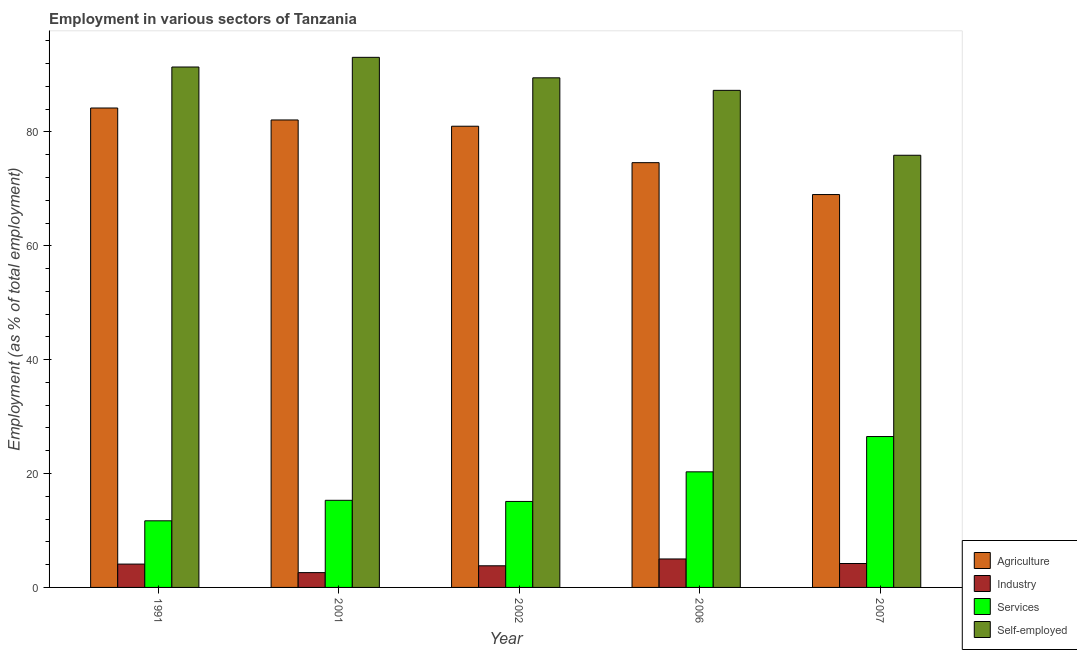Are the number of bars per tick equal to the number of legend labels?
Make the answer very short. Yes. How many bars are there on the 3rd tick from the left?
Your answer should be very brief. 4. What is the percentage of self employed workers in 2007?
Offer a terse response. 75.9. Across all years, what is the maximum percentage of self employed workers?
Your response must be concise. 93.1. Across all years, what is the minimum percentage of workers in agriculture?
Your answer should be compact. 69. In which year was the percentage of self employed workers minimum?
Your answer should be compact. 2007. What is the total percentage of workers in agriculture in the graph?
Make the answer very short. 390.9. What is the difference between the percentage of workers in agriculture in 1991 and that in 2002?
Make the answer very short. 3.2. What is the difference between the percentage of workers in agriculture in 2001 and the percentage of workers in services in 2006?
Your answer should be very brief. 7.5. What is the average percentage of self employed workers per year?
Provide a short and direct response. 87.44. What is the ratio of the percentage of workers in industry in 2002 to that in 2006?
Your response must be concise. 0.76. Is the percentage of self employed workers in 1991 less than that in 2002?
Give a very brief answer. No. What is the difference between the highest and the second highest percentage of workers in services?
Your answer should be very brief. 6.2. What is the difference between the highest and the lowest percentage of workers in services?
Ensure brevity in your answer.  14.8. Is it the case that in every year, the sum of the percentage of self employed workers and percentage of workers in services is greater than the sum of percentage of workers in agriculture and percentage of workers in industry?
Ensure brevity in your answer.  Yes. What does the 1st bar from the left in 2001 represents?
Your answer should be very brief. Agriculture. What does the 4th bar from the right in 2006 represents?
Your answer should be very brief. Agriculture. Is it the case that in every year, the sum of the percentage of workers in agriculture and percentage of workers in industry is greater than the percentage of workers in services?
Your answer should be compact. Yes. How many bars are there?
Give a very brief answer. 20. Are all the bars in the graph horizontal?
Your answer should be very brief. No. Does the graph contain any zero values?
Your answer should be very brief. No. Where does the legend appear in the graph?
Offer a terse response. Bottom right. How many legend labels are there?
Your response must be concise. 4. What is the title of the graph?
Provide a short and direct response. Employment in various sectors of Tanzania. Does "Management rating" appear as one of the legend labels in the graph?
Offer a very short reply. No. What is the label or title of the Y-axis?
Provide a short and direct response. Employment (as % of total employment). What is the Employment (as % of total employment) in Agriculture in 1991?
Offer a terse response. 84.2. What is the Employment (as % of total employment) of Industry in 1991?
Your answer should be very brief. 4.1. What is the Employment (as % of total employment) in Services in 1991?
Make the answer very short. 11.7. What is the Employment (as % of total employment) of Self-employed in 1991?
Your answer should be very brief. 91.4. What is the Employment (as % of total employment) of Agriculture in 2001?
Your answer should be compact. 82.1. What is the Employment (as % of total employment) of Industry in 2001?
Your answer should be very brief. 2.6. What is the Employment (as % of total employment) in Services in 2001?
Your answer should be compact. 15.3. What is the Employment (as % of total employment) of Self-employed in 2001?
Your response must be concise. 93.1. What is the Employment (as % of total employment) of Agriculture in 2002?
Your answer should be compact. 81. What is the Employment (as % of total employment) in Industry in 2002?
Offer a very short reply. 3.8. What is the Employment (as % of total employment) of Services in 2002?
Your answer should be compact. 15.1. What is the Employment (as % of total employment) in Self-employed in 2002?
Your response must be concise. 89.5. What is the Employment (as % of total employment) in Agriculture in 2006?
Provide a succinct answer. 74.6. What is the Employment (as % of total employment) in Industry in 2006?
Make the answer very short. 5. What is the Employment (as % of total employment) in Services in 2006?
Your answer should be compact. 20.3. What is the Employment (as % of total employment) of Self-employed in 2006?
Provide a succinct answer. 87.3. What is the Employment (as % of total employment) in Agriculture in 2007?
Ensure brevity in your answer.  69. What is the Employment (as % of total employment) in Industry in 2007?
Provide a succinct answer. 4.2. What is the Employment (as % of total employment) of Self-employed in 2007?
Your answer should be very brief. 75.9. Across all years, what is the maximum Employment (as % of total employment) in Agriculture?
Provide a succinct answer. 84.2. Across all years, what is the maximum Employment (as % of total employment) of Industry?
Make the answer very short. 5. Across all years, what is the maximum Employment (as % of total employment) in Services?
Your response must be concise. 26.5. Across all years, what is the maximum Employment (as % of total employment) of Self-employed?
Give a very brief answer. 93.1. Across all years, what is the minimum Employment (as % of total employment) in Agriculture?
Provide a succinct answer. 69. Across all years, what is the minimum Employment (as % of total employment) of Industry?
Offer a very short reply. 2.6. Across all years, what is the minimum Employment (as % of total employment) of Services?
Provide a short and direct response. 11.7. Across all years, what is the minimum Employment (as % of total employment) in Self-employed?
Make the answer very short. 75.9. What is the total Employment (as % of total employment) in Agriculture in the graph?
Your answer should be compact. 390.9. What is the total Employment (as % of total employment) in Industry in the graph?
Keep it short and to the point. 19.7. What is the total Employment (as % of total employment) in Services in the graph?
Your response must be concise. 88.9. What is the total Employment (as % of total employment) of Self-employed in the graph?
Your answer should be very brief. 437.2. What is the difference between the Employment (as % of total employment) in Agriculture in 1991 and that in 2001?
Offer a terse response. 2.1. What is the difference between the Employment (as % of total employment) of Self-employed in 1991 and that in 2001?
Your answer should be very brief. -1.7. What is the difference between the Employment (as % of total employment) in Industry in 1991 and that in 2002?
Make the answer very short. 0.3. What is the difference between the Employment (as % of total employment) in Services in 1991 and that in 2002?
Provide a succinct answer. -3.4. What is the difference between the Employment (as % of total employment) of Self-employed in 1991 and that in 2002?
Your response must be concise. 1.9. What is the difference between the Employment (as % of total employment) of Agriculture in 1991 and that in 2006?
Offer a terse response. 9.6. What is the difference between the Employment (as % of total employment) of Industry in 1991 and that in 2006?
Offer a terse response. -0.9. What is the difference between the Employment (as % of total employment) in Services in 1991 and that in 2007?
Ensure brevity in your answer.  -14.8. What is the difference between the Employment (as % of total employment) in Self-employed in 1991 and that in 2007?
Your answer should be compact. 15.5. What is the difference between the Employment (as % of total employment) in Agriculture in 2001 and that in 2002?
Your answer should be very brief. 1.1. What is the difference between the Employment (as % of total employment) of Self-employed in 2001 and that in 2002?
Give a very brief answer. 3.6. What is the difference between the Employment (as % of total employment) of Agriculture in 2001 and that in 2006?
Your answer should be compact. 7.5. What is the difference between the Employment (as % of total employment) in Industry in 2001 and that in 2006?
Offer a terse response. -2.4. What is the difference between the Employment (as % of total employment) in Services in 2001 and that in 2006?
Ensure brevity in your answer.  -5. What is the difference between the Employment (as % of total employment) of Self-employed in 2001 and that in 2006?
Give a very brief answer. 5.8. What is the difference between the Employment (as % of total employment) of Industry in 2001 and that in 2007?
Provide a succinct answer. -1.6. What is the difference between the Employment (as % of total employment) in Services in 2001 and that in 2007?
Give a very brief answer. -11.2. What is the difference between the Employment (as % of total employment) of Self-employed in 2001 and that in 2007?
Keep it short and to the point. 17.2. What is the difference between the Employment (as % of total employment) of Services in 2002 and that in 2006?
Your answer should be very brief. -5.2. What is the difference between the Employment (as % of total employment) of Agriculture in 2002 and that in 2007?
Ensure brevity in your answer.  12. What is the difference between the Employment (as % of total employment) in Industry in 2006 and that in 2007?
Your answer should be very brief. 0.8. What is the difference between the Employment (as % of total employment) in Services in 2006 and that in 2007?
Offer a very short reply. -6.2. What is the difference between the Employment (as % of total employment) of Self-employed in 2006 and that in 2007?
Make the answer very short. 11.4. What is the difference between the Employment (as % of total employment) of Agriculture in 1991 and the Employment (as % of total employment) of Industry in 2001?
Ensure brevity in your answer.  81.6. What is the difference between the Employment (as % of total employment) of Agriculture in 1991 and the Employment (as % of total employment) of Services in 2001?
Give a very brief answer. 68.9. What is the difference between the Employment (as % of total employment) of Agriculture in 1991 and the Employment (as % of total employment) of Self-employed in 2001?
Offer a terse response. -8.9. What is the difference between the Employment (as % of total employment) of Industry in 1991 and the Employment (as % of total employment) of Services in 2001?
Provide a short and direct response. -11.2. What is the difference between the Employment (as % of total employment) of Industry in 1991 and the Employment (as % of total employment) of Self-employed in 2001?
Ensure brevity in your answer.  -89. What is the difference between the Employment (as % of total employment) of Services in 1991 and the Employment (as % of total employment) of Self-employed in 2001?
Offer a terse response. -81.4. What is the difference between the Employment (as % of total employment) of Agriculture in 1991 and the Employment (as % of total employment) of Industry in 2002?
Your answer should be very brief. 80.4. What is the difference between the Employment (as % of total employment) in Agriculture in 1991 and the Employment (as % of total employment) in Services in 2002?
Your answer should be very brief. 69.1. What is the difference between the Employment (as % of total employment) in Agriculture in 1991 and the Employment (as % of total employment) in Self-employed in 2002?
Offer a terse response. -5.3. What is the difference between the Employment (as % of total employment) of Industry in 1991 and the Employment (as % of total employment) of Self-employed in 2002?
Your response must be concise. -85.4. What is the difference between the Employment (as % of total employment) of Services in 1991 and the Employment (as % of total employment) of Self-employed in 2002?
Provide a succinct answer. -77.8. What is the difference between the Employment (as % of total employment) in Agriculture in 1991 and the Employment (as % of total employment) in Industry in 2006?
Keep it short and to the point. 79.2. What is the difference between the Employment (as % of total employment) of Agriculture in 1991 and the Employment (as % of total employment) of Services in 2006?
Give a very brief answer. 63.9. What is the difference between the Employment (as % of total employment) in Agriculture in 1991 and the Employment (as % of total employment) in Self-employed in 2006?
Your answer should be compact. -3.1. What is the difference between the Employment (as % of total employment) of Industry in 1991 and the Employment (as % of total employment) of Services in 2006?
Your answer should be very brief. -16.2. What is the difference between the Employment (as % of total employment) in Industry in 1991 and the Employment (as % of total employment) in Self-employed in 2006?
Keep it short and to the point. -83.2. What is the difference between the Employment (as % of total employment) in Services in 1991 and the Employment (as % of total employment) in Self-employed in 2006?
Keep it short and to the point. -75.6. What is the difference between the Employment (as % of total employment) in Agriculture in 1991 and the Employment (as % of total employment) in Industry in 2007?
Your answer should be very brief. 80. What is the difference between the Employment (as % of total employment) of Agriculture in 1991 and the Employment (as % of total employment) of Services in 2007?
Your answer should be very brief. 57.7. What is the difference between the Employment (as % of total employment) in Industry in 1991 and the Employment (as % of total employment) in Services in 2007?
Ensure brevity in your answer.  -22.4. What is the difference between the Employment (as % of total employment) in Industry in 1991 and the Employment (as % of total employment) in Self-employed in 2007?
Your answer should be compact. -71.8. What is the difference between the Employment (as % of total employment) in Services in 1991 and the Employment (as % of total employment) in Self-employed in 2007?
Offer a very short reply. -64.2. What is the difference between the Employment (as % of total employment) in Agriculture in 2001 and the Employment (as % of total employment) in Industry in 2002?
Provide a succinct answer. 78.3. What is the difference between the Employment (as % of total employment) of Agriculture in 2001 and the Employment (as % of total employment) of Self-employed in 2002?
Keep it short and to the point. -7.4. What is the difference between the Employment (as % of total employment) of Industry in 2001 and the Employment (as % of total employment) of Services in 2002?
Ensure brevity in your answer.  -12.5. What is the difference between the Employment (as % of total employment) in Industry in 2001 and the Employment (as % of total employment) in Self-employed in 2002?
Offer a very short reply. -86.9. What is the difference between the Employment (as % of total employment) in Services in 2001 and the Employment (as % of total employment) in Self-employed in 2002?
Provide a short and direct response. -74.2. What is the difference between the Employment (as % of total employment) of Agriculture in 2001 and the Employment (as % of total employment) of Industry in 2006?
Make the answer very short. 77.1. What is the difference between the Employment (as % of total employment) in Agriculture in 2001 and the Employment (as % of total employment) in Services in 2006?
Keep it short and to the point. 61.8. What is the difference between the Employment (as % of total employment) in Industry in 2001 and the Employment (as % of total employment) in Services in 2006?
Give a very brief answer. -17.7. What is the difference between the Employment (as % of total employment) of Industry in 2001 and the Employment (as % of total employment) of Self-employed in 2006?
Ensure brevity in your answer.  -84.7. What is the difference between the Employment (as % of total employment) in Services in 2001 and the Employment (as % of total employment) in Self-employed in 2006?
Your answer should be very brief. -72. What is the difference between the Employment (as % of total employment) in Agriculture in 2001 and the Employment (as % of total employment) in Industry in 2007?
Offer a terse response. 77.9. What is the difference between the Employment (as % of total employment) of Agriculture in 2001 and the Employment (as % of total employment) of Services in 2007?
Offer a terse response. 55.6. What is the difference between the Employment (as % of total employment) of Agriculture in 2001 and the Employment (as % of total employment) of Self-employed in 2007?
Your answer should be compact. 6.2. What is the difference between the Employment (as % of total employment) of Industry in 2001 and the Employment (as % of total employment) of Services in 2007?
Give a very brief answer. -23.9. What is the difference between the Employment (as % of total employment) in Industry in 2001 and the Employment (as % of total employment) in Self-employed in 2007?
Offer a terse response. -73.3. What is the difference between the Employment (as % of total employment) of Services in 2001 and the Employment (as % of total employment) of Self-employed in 2007?
Your answer should be very brief. -60.6. What is the difference between the Employment (as % of total employment) in Agriculture in 2002 and the Employment (as % of total employment) in Industry in 2006?
Ensure brevity in your answer.  76. What is the difference between the Employment (as % of total employment) of Agriculture in 2002 and the Employment (as % of total employment) of Services in 2006?
Give a very brief answer. 60.7. What is the difference between the Employment (as % of total employment) in Agriculture in 2002 and the Employment (as % of total employment) in Self-employed in 2006?
Your answer should be very brief. -6.3. What is the difference between the Employment (as % of total employment) in Industry in 2002 and the Employment (as % of total employment) in Services in 2006?
Offer a very short reply. -16.5. What is the difference between the Employment (as % of total employment) in Industry in 2002 and the Employment (as % of total employment) in Self-employed in 2006?
Your answer should be very brief. -83.5. What is the difference between the Employment (as % of total employment) of Services in 2002 and the Employment (as % of total employment) of Self-employed in 2006?
Offer a very short reply. -72.2. What is the difference between the Employment (as % of total employment) in Agriculture in 2002 and the Employment (as % of total employment) in Industry in 2007?
Make the answer very short. 76.8. What is the difference between the Employment (as % of total employment) in Agriculture in 2002 and the Employment (as % of total employment) in Services in 2007?
Give a very brief answer. 54.5. What is the difference between the Employment (as % of total employment) in Agriculture in 2002 and the Employment (as % of total employment) in Self-employed in 2007?
Make the answer very short. 5.1. What is the difference between the Employment (as % of total employment) in Industry in 2002 and the Employment (as % of total employment) in Services in 2007?
Your answer should be very brief. -22.7. What is the difference between the Employment (as % of total employment) in Industry in 2002 and the Employment (as % of total employment) in Self-employed in 2007?
Provide a short and direct response. -72.1. What is the difference between the Employment (as % of total employment) in Services in 2002 and the Employment (as % of total employment) in Self-employed in 2007?
Your response must be concise. -60.8. What is the difference between the Employment (as % of total employment) in Agriculture in 2006 and the Employment (as % of total employment) in Industry in 2007?
Give a very brief answer. 70.4. What is the difference between the Employment (as % of total employment) in Agriculture in 2006 and the Employment (as % of total employment) in Services in 2007?
Make the answer very short. 48.1. What is the difference between the Employment (as % of total employment) in Agriculture in 2006 and the Employment (as % of total employment) in Self-employed in 2007?
Make the answer very short. -1.3. What is the difference between the Employment (as % of total employment) of Industry in 2006 and the Employment (as % of total employment) of Services in 2007?
Offer a terse response. -21.5. What is the difference between the Employment (as % of total employment) in Industry in 2006 and the Employment (as % of total employment) in Self-employed in 2007?
Give a very brief answer. -70.9. What is the difference between the Employment (as % of total employment) of Services in 2006 and the Employment (as % of total employment) of Self-employed in 2007?
Your answer should be compact. -55.6. What is the average Employment (as % of total employment) in Agriculture per year?
Ensure brevity in your answer.  78.18. What is the average Employment (as % of total employment) in Industry per year?
Keep it short and to the point. 3.94. What is the average Employment (as % of total employment) in Services per year?
Provide a short and direct response. 17.78. What is the average Employment (as % of total employment) of Self-employed per year?
Your answer should be compact. 87.44. In the year 1991, what is the difference between the Employment (as % of total employment) of Agriculture and Employment (as % of total employment) of Industry?
Your answer should be compact. 80.1. In the year 1991, what is the difference between the Employment (as % of total employment) of Agriculture and Employment (as % of total employment) of Services?
Give a very brief answer. 72.5. In the year 1991, what is the difference between the Employment (as % of total employment) of Agriculture and Employment (as % of total employment) of Self-employed?
Provide a succinct answer. -7.2. In the year 1991, what is the difference between the Employment (as % of total employment) in Industry and Employment (as % of total employment) in Self-employed?
Your answer should be compact. -87.3. In the year 1991, what is the difference between the Employment (as % of total employment) in Services and Employment (as % of total employment) in Self-employed?
Make the answer very short. -79.7. In the year 2001, what is the difference between the Employment (as % of total employment) in Agriculture and Employment (as % of total employment) in Industry?
Your answer should be compact. 79.5. In the year 2001, what is the difference between the Employment (as % of total employment) of Agriculture and Employment (as % of total employment) of Services?
Provide a succinct answer. 66.8. In the year 2001, what is the difference between the Employment (as % of total employment) in Agriculture and Employment (as % of total employment) in Self-employed?
Ensure brevity in your answer.  -11. In the year 2001, what is the difference between the Employment (as % of total employment) in Industry and Employment (as % of total employment) in Self-employed?
Your answer should be compact. -90.5. In the year 2001, what is the difference between the Employment (as % of total employment) in Services and Employment (as % of total employment) in Self-employed?
Your answer should be compact. -77.8. In the year 2002, what is the difference between the Employment (as % of total employment) in Agriculture and Employment (as % of total employment) in Industry?
Offer a very short reply. 77.2. In the year 2002, what is the difference between the Employment (as % of total employment) of Agriculture and Employment (as % of total employment) of Services?
Your answer should be compact. 65.9. In the year 2002, what is the difference between the Employment (as % of total employment) of Industry and Employment (as % of total employment) of Services?
Your response must be concise. -11.3. In the year 2002, what is the difference between the Employment (as % of total employment) of Industry and Employment (as % of total employment) of Self-employed?
Your answer should be compact. -85.7. In the year 2002, what is the difference between the Employment (as % of total employment) in Services and Employment (as % of total employment) in Self-employed?
Make the answer very short. -74.4. In the year 2006, what is the difference between the Employment (as % of total employment) of Agriculture and Employment (as % of total employment) of Industry?
Provide a succinct answer. 69.6. In the year 2006, what is the difference between the Employment (as % of total employment) in Agriculture and Employment (as % of total employment) in Services?
Make the answer very short. 54.3. In the year 2006, what is the difference between the Employment (as % of total employment) in Agriculture and Employment (as % of total employment) in Self-employed?
Offer a terse response. -12.7. In the year 2006, what is the difference between the Employment (as % of total employment) in Industry and Employment (as % of total employment) in Services?
Ensure brevity in your answer.  -15.3. In the year 2006, what is the difference between the Employment (as % of total employment) of Industry and Employment (as % of total employment) of Self-employed?
Offer a very short reply. -82.3. In the year 2006, what is the difference between the Employment (as % of total employment) in Services and Employment (as % of total employment) in Self-employed?
Your response must be concise. -67. In the year 2007, what is the difference between the Employment (as % of total employment) in Agriculture and Employment (as % of total employment) in Industry?
Provide a short and direct response. 64.8. In the year 2007, what is the difference between the Employment (as % of total employment) in Agriculture and Employment (as % of total employment) in Services?
Your response must be concise. 42.5. In the year 2007, what is the difference between the Employment (as % of total employment) of Agriculture and Employment (as % of total employment) of Self-employed?
Make the answer very short. -6.9. In the year 2007, what is the difference between the Employment (as % of total employment) in Industry and Employment (as % of total employment) in Services?
Offer a terse response. -22.3. In the year 2007, what is the difference between the Employment (as % of total employment) in Industry and Employment (as % of total employment) in Self-employed?
Your answer should be very brief. -71.7. In the year 2007, what is the difference between the Employment (as % of total employment) in Services and Employment (as % of total employment) in Self-employed?
Ensure brevity in your answer.  -49.4. What is the ratio of the Employment (as % of total employment) in Agriculture in 1991 to that in 2001?
Make the answer very short. 1.03. What is the ratio of the Employment (as % of total employment) of Industry in 1991 to that in 2001?
Give a very brief answer. 1.58. What is the ratio of the Employment (as % of total employment) in Services in 1991 to that in 2001?
Offer a very short reply. 0.76. What is the ratio of the Employment (as % of total employment) in Self-employed in 1991 to that in 2001?
Your answer should be compact. 0.98. What is the ratio of the Employment (as % of total employment) in Agriculture in 1991 to that in 2002?
Your answer should be compact. 1.04. What is the ratio of the Employment (as % of total employment) of Industry in 1991 to that in 2002?
Offer a very short reply. 1.08. What is the ratio of the Employment (as % of total employment) of Services in 1991 to that in 2002?
Make the answer very short. 0.77. What is the ratio of the Employment (as % of total employment) of Self-employed in 1991 to that in 2002?
Give a very brief answer. 1.02. What is the ratio of the Employment (as % of total employment) of Agriculture in 1991 to that in 2006?
Your answer should be very brief. 1.13. What is the ratio of the Employment (as % of total employment) of Industry in 1991 to that in 2006?
Your answer should be very brief. 0.82. What is the ratio of the Employment (as % of total employment) in Services in 1991 to that in 2006?
Provide a short and direct response. 0.58. What is the ratio of the Employment (as % of total employment) in Self-employed in 1991 to that in 2006?
Your response must be concise. 1.05. What is the ratio of the Employment (as % of total employment) of Agriculture in 1991 to that in 2007?
Make the answer very short. 1.22. What is the ratio of the Employment (as % of total employment) in Industry in 1991 to that in 2007?
Offer a terse response. 0.98. What is the ratio of the Employment (as % of total employment) of Services in 1991 to that in 2007?
Ensure brevity in your answer.  0.44. What is the ratio of the Employment (as % of total employment) of Self-employed in 1991 to that in 2007?
Provide a short and direct response. 1.2. What is the ratio of the Employment (as % of total employment) of Agriculture in 2001 to that in 2002?
Your answer should be very brief. 1.01. What is the ratio of the Employment (as % of total employment) in Industry in 2001 to that in 2002?
Your answer should be very brief. 0.68. What is the ratio of the Employment (as % of total employment) in Services in 2001 to that in 2002?
Your answer should be very brief. 1.01. What is the ratio of the Employment (as % of total employment) in Self-employed in 2001 to that in 2002?
Give a very brief answer. 1.04. What is the ratio of the Employment (as % of total employment) in Agriculture in 2001 to that in 2006?
Your answer should be very brief. 1.1. What is the ratio of the Employment (as % of total employment) in Industry in 2001 to that in 2006?
Ensure brevity in your answer.  0.52. What is the ratio of the Employment (as % of total employment) of Services in 2001 to that in 2006?
Offer a terse response. 0.75. What is the ratio of the Employment (as % of total employment) of Self-employed in 2001 to that in 2006?
Your answer should be compact. 1.07. What is the ratio of the Employment (as % of total employment) in Agriculture in 2001 to that in 2007?
Give a very brief answer. 1.19. What is the ratio of the Employment (as % of total employment) of Industry in 2001 to that in 2007?
Offer a terse response. 0.62. What is the ratio of the Employment (as % of total employment) in Services in 2001 to that in 2007?
Offer a very short reply. 0.58. What is the ratio of the Employment (as % of total employment) in Self-employed in 2001 to that in 2007?
Keep it short and to the point. 1.23. What is the ratio of the Employment (as % of total employment) of Agriculture in 2002 to that in 2006?
Make the answer very short. 1.09. What is the ratio of the Employment (as % of total employment) of Industry in 2002 to that in 2006?
Provide a short and direct response. 0.76. What is the ratio of the Employment (as % of total employment) in Services in 2002 to that in 2006?
Your answer should be compact. 0.74. What is the ratio of the Employment (as % of total employment) of Self-employed in 2002 to that in 2006?
Offer a terse response. 1.03. What is the ratio of the Employment (as % of total employment) in Agriculture in 2002 to that in 2007?
Ensure brevity in your answer.  1.17. What is the ratio of the Employment (as % of total employment) of Industry in 2002 to that in 2007?
Give a very brief answer. 0.9. What is the ratio of the Employment (as % of total employment) of Services in 2002 to that in 2007?
Provide a short and direct response. 0.57. What is the ratio of the Employment (as % of total employment) in Self-employed in 2002 to that in 2007?
Your response must be concise. 1.18. What is the ratio of the Employment (as % of total employment) in Agriculture in 2006 to that in 2007?
Provide a short and direct response. 1.08. What is the ratio of the Employment (as % of total employment) in Industry in 2006 to that in 2007?
Give a very brief answer. 1.19. What is the ratio of the Employment (as % of total employment) in Services in 2006 to that in 2007?
Your response must be concise. 0.77. What is the ratio of the Employment (as % of total employment) of Self-employed in 2006 to that in 2007?
Make the answer very short. 1.15. What is the difference between the highest and the second highest Employment (as % of total employment) of Agriculture?
Ensure brevity in your answer.  2.1. What is the difference between the highest and the lowest Employment (as % of total employment) of Services?
Your response must be concise. 14.8. What is the difference between the highest and the lowest Employment (as % of total employment) of Self-employed?
Keep it short and to the point. 17.2. 